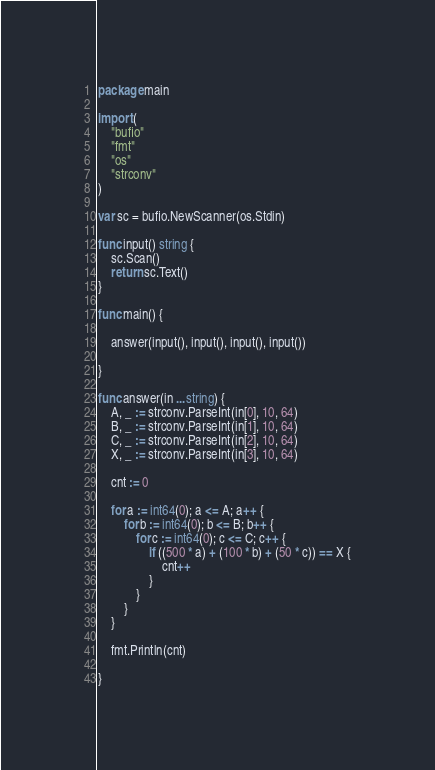Convert code to text. <code><loc_0><loc_0><loc_500><loc_500><_Go_>package main

import (
	"bufio"
	"fmt"
	"os"
	"strconv"
)

var sc = bufio.NewScanner(os.Stdin)

func input() string {
	sc.Scan()
	return sc.Text()
}

func main() {

	answer(input(), input(), input(), input())

}

func answer(in ...string) {
	A, _ := strconv.ParseInt(in[0], 10, 64)
	B, _ := strconv.ParseInt(in[1], 10, 64)
	C, _ := strconv.ParseInt(in[2], 10, 64)
	X, _ := strconv.ParseInt(in[3], 10, 64)

	cnt := 0

	for a := int64(0); a <= A; a++ {
		for b := int64(0); b <= B; b++ {
			for c := int64(0); c <= C; c++ {
				if ((500 * a) + (100 * b) + (50 * c)) == X {
					cnt++
				}
			}
		}
	}

	fmt.Println(cnt)

}
</code> 